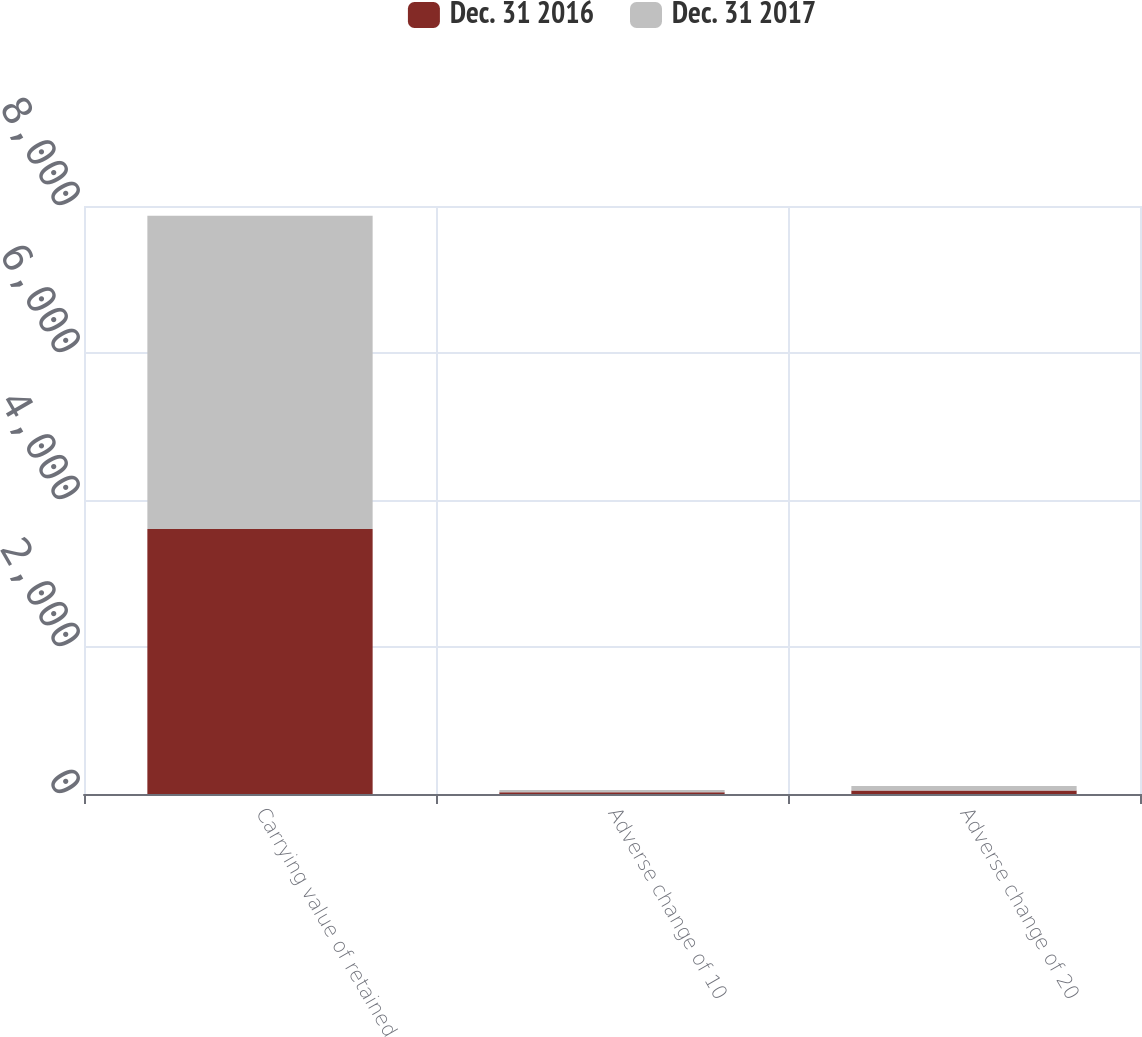Convert chart to OTSL. <chart><loc_0><loc_0><loc_500><loc_500><stacked_bar_chart><ecel><fcel>Carrying value of retained<fcel>Adverse change of 10<fcel>Adverse change of 20<nl><fcel>Dec. 31 2016<fcel>3607<fcel>24<fcel>47<nl><fcel>Dec. 31 2017<fcel>4261<fcel>30<fcel>62<nl></chart> 